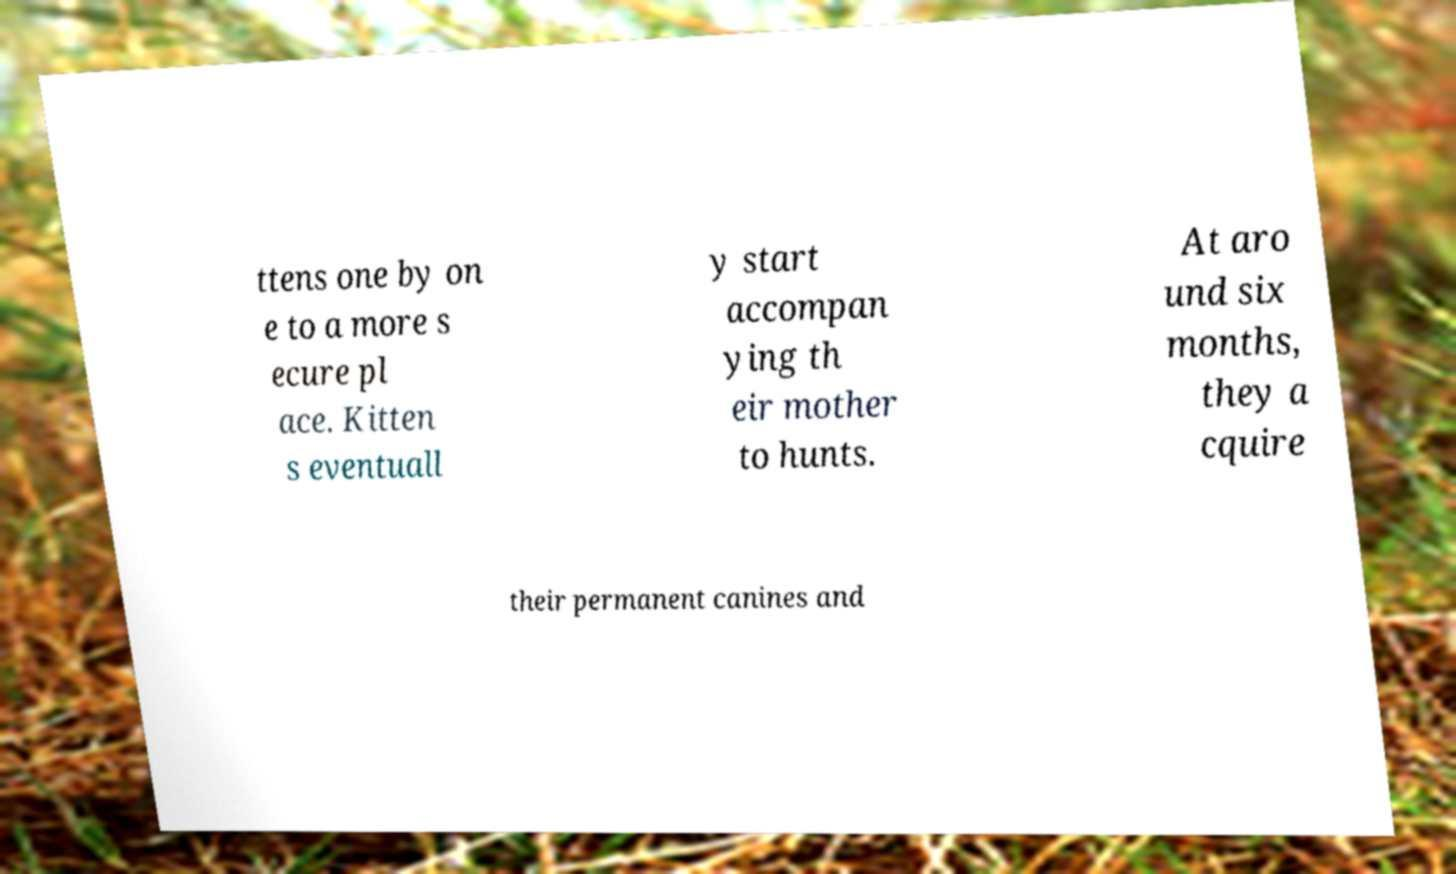Could you assist in decoding the text presented in this image and type it out clearly? ttens one by on e to a more s ecure pl ace. Kitten s eventuall y start accompan ying th eir mother to hunts. At aro und six months, they a cquire their permanent canines and 